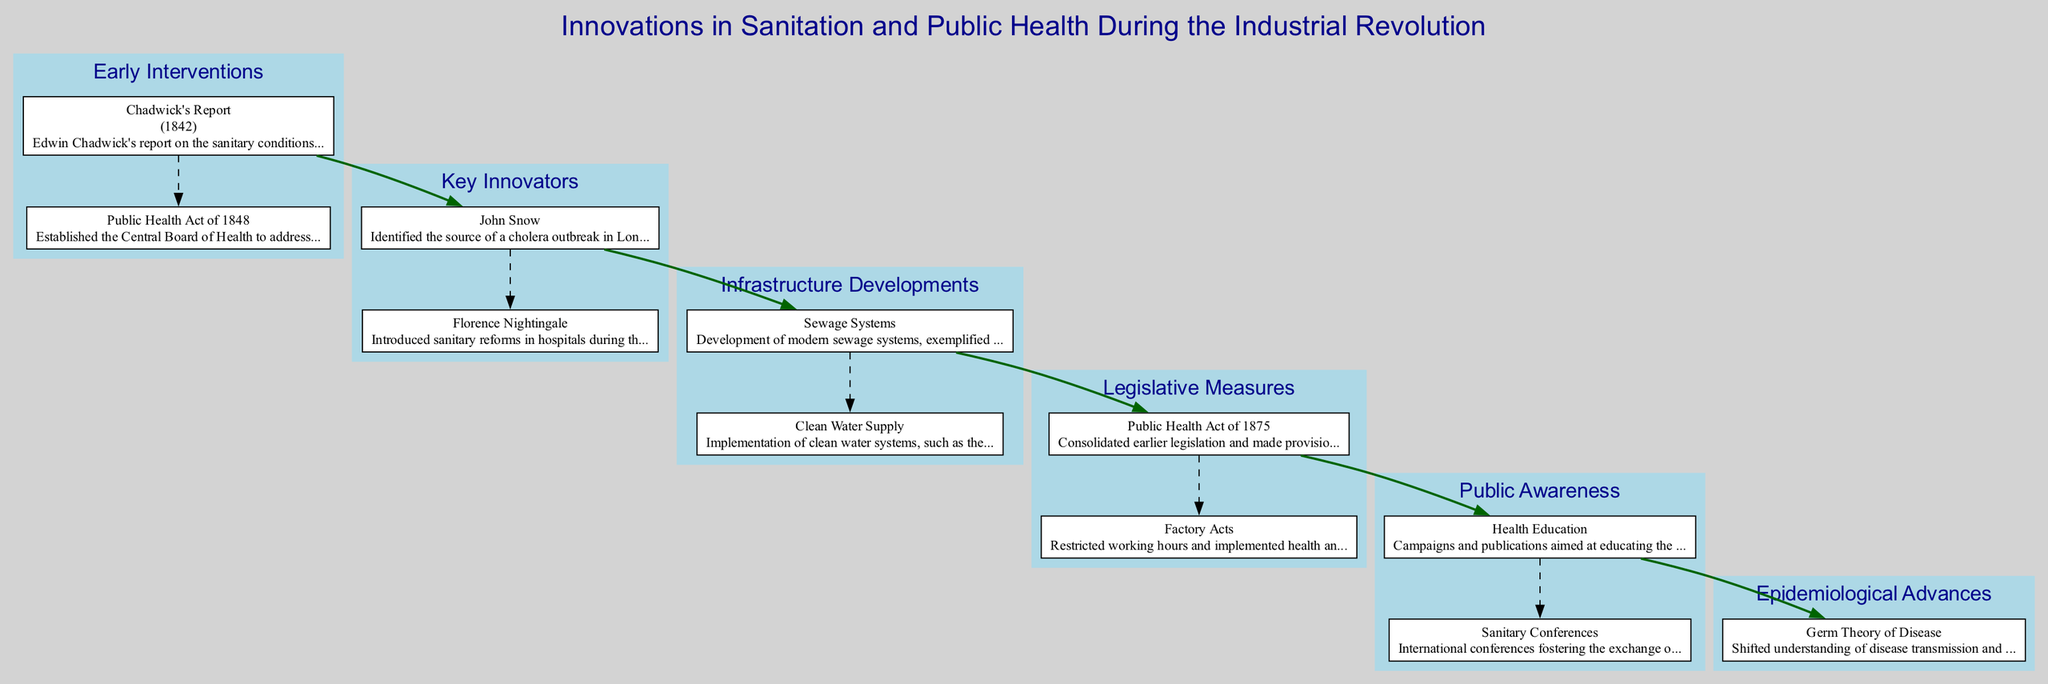What year was Chadwick's Report published? Chadwick's Report is listed under the "Early Interventions" category, and it specifically states the year of publication as 1842.
Answer: 1842 Who identified the source of the cholera outbreak in London? The "Key Innovators" section of the diagram cites John Snow as the person who identified the source of a cholera outbreak in London in 1854.
Answer: John Snow What legislation consolidated earlier public health laws in 1875? The "Legislative Measures" section includes the Public Health Act of 1875, which is described as consolidating earlier legislation.
Answer: Public Health Act of 1875 What was a key achievement of Florence Nightingale? Under "Key Innovators", Florence Nightingale is noted for introducing sanitary reforms in hospitals during the Crimean War, which represents her significant achievement.
Answer: Introduced sanitary reforms How did the germ theory impact public health measures? The "Epidemiological Advances" section describes the germ theory of disease as shifting the understanding of disease transmission and leading to improved public health measures, indicating a significant connection between the theory and health practices.
Answer: Shifted understanding of disease transmission Which public health act established the Central Board of Health? The "Early Interventions" category includes the Public Health Act of 1848, which established the Central Board of Health to address sanitary issues.
Answer: Public Health Act of 1848 What major infrastructure development was inaugurated in 1865? The diagram notes the development of sewage systems, specifically mentioning Joseph Bazalgette's London sewer system inaugurated in 1865, representing a major development in public health infrastructure.
Answer: London sewer system What type of campaigns aimed to educate the public on hygiene practices? The "Public Awareness" section points to Health Education campaigns that were aimed at educating the public on hygiene practices, highlighting the focus on improving public awareness.
Answer: Health Education How are the connections represented in the diagram between the nodes of different categories? The diagram’s design includes bold connections between the categories, specifically linking elements such as "Early Interventions" to "Key Innovators," indicating a progression in public health developments.
Answer: Bold connections between categories 